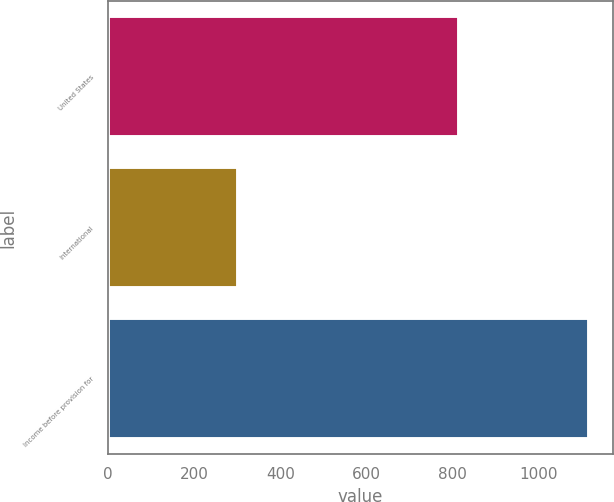Convert chart to OTSL. <chart><loc_0><loc_0><loc_500><loc_500><bar_chart><fcel>United States<fcel>International<fcel>Income before provision for<nl><fcel>814.7<fcel>302<fcel>1116.7<nl></chart> 